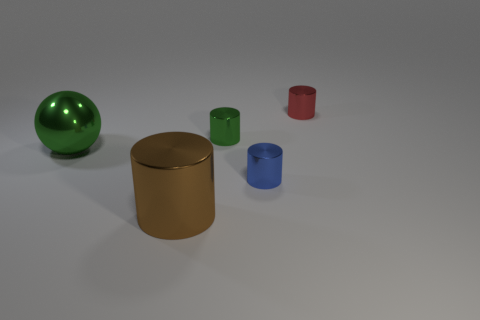How many other objects are there of the same shape as the tiny red object?
Offer a very short reply. 3. There is a large green object; is its shape the same as the green metallic thing that is to the right of the large ball?
Offer a very short reply. No. There is a brown thing that is the same shape as the tiny blue metal thing; what is it made of?
Offer a very short reply. Metal. What number of big objects are brown objects or balls?
Keep it short and to the point. 2. Are there fewer shiny cylinders that are behind the blue thing than small metallic objects on the left side of the green metallic cylinder?
Provide a succinct answer. No. What number of things are tiny green objects or green metal spheres?
Your answer should be very brief. 2. There is a blue metal object; what number of small things are to the left of it?
Your answer should be very brief. 1. What is the shape of the large brown object that is made of the same material as the small red cylinder?
Your answer should be very brief. Cylinder. Do the green object on the right side of the big brown cylinder and the brown metal object have the same shape?
Your answer should be very brief. Yes. What number of gray things are either big metal cylinders or metallic cylinders?
Offer a terse response. 0. 